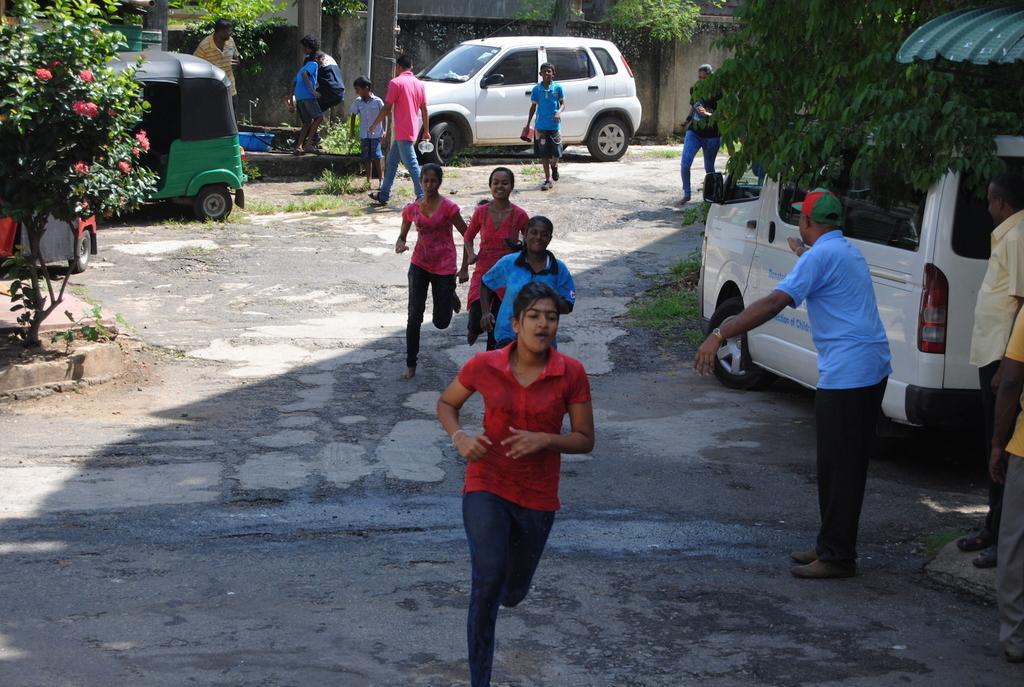In one or two sentences, can you explain what this image depicts? In the foreground of the picture I can see four girls running on the road. I can see three persons on the right side and I can see one of them is wearing a blue color T-shirt and looks like he is speaking by indicating something with his hands. I can see a minivan on the right side. There is a flower plant on the top left side of the picture. I can see two vehicles on the top left side. In the background, I can see a few persons and a car. I can see a water tap and blue color bucket on the top left side. 